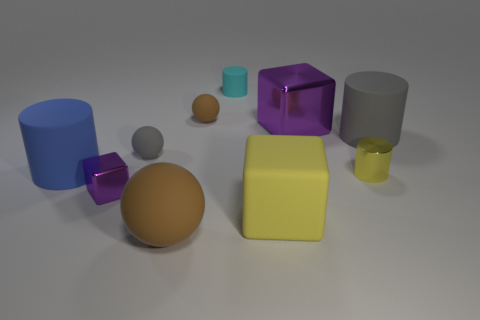What shapes and colors do you see in the image? In this image, there is an assortment of geometric shapes, including a blue cylinder, a brown sphere, a purple transparent cube, a yellow cube, and a grey cylinder. The colors are quite vibrant and make for a visually stimulating collection. 